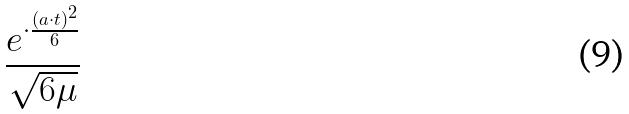<formula> <loc_0><loc_0><loc_500><loc_500>\frac { e ^ { \cdot \frac { ( a \cdot t ) ^ { 2 } } { 6 } } } { \sqrt { 6 \mu } }</formula> 